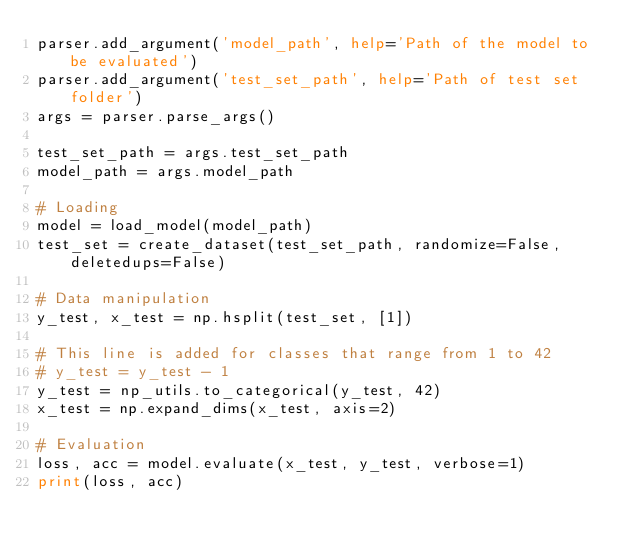Convert code to text. <code><loc_0><loc_0><loc_500><loc_500><_Python_>parser.add_argument('model_path', help='Path of the model to be evaluated')
parser.add_argument('test_set_path', help='Path of test set folder')
args = parser.parse_args()

test_set_path = args.test_set_path
model_path = args.model_path

# Loading
model = load_model(model_path)
test_set = create_dataset(test_set_path, randomize=False, deletedups=False)

# Data manipulation
y_test, x_test = np.hsplit(test_set, [1])

# This line is added for classes that range from 1 to 42
# y_test = y_test - 1
y_test = np_utils.to_categorical(y_test, 42)
x_test = np.expand_dims(x_test, axis=2)

# Evaluation
loss, acc = model.evaluate(x_test, y_test, verbose=1)
print(loss, acc)
</code> 